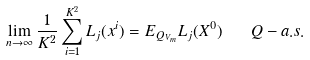<formula> <loc_0><loc_0><loc_500><loc_500>\lim _ { n \to \infty } \frac { 1 } { K ^ { 2 } } \sum _ { i = 1 } ^ { K ^ { 2 } } { L _ { j } ( x ^ { i } ) } = E _ { Q _ { V _ { m } } } L _ { j } ( X ^ { 0 } ) \quad Q - a . s .</formula> 